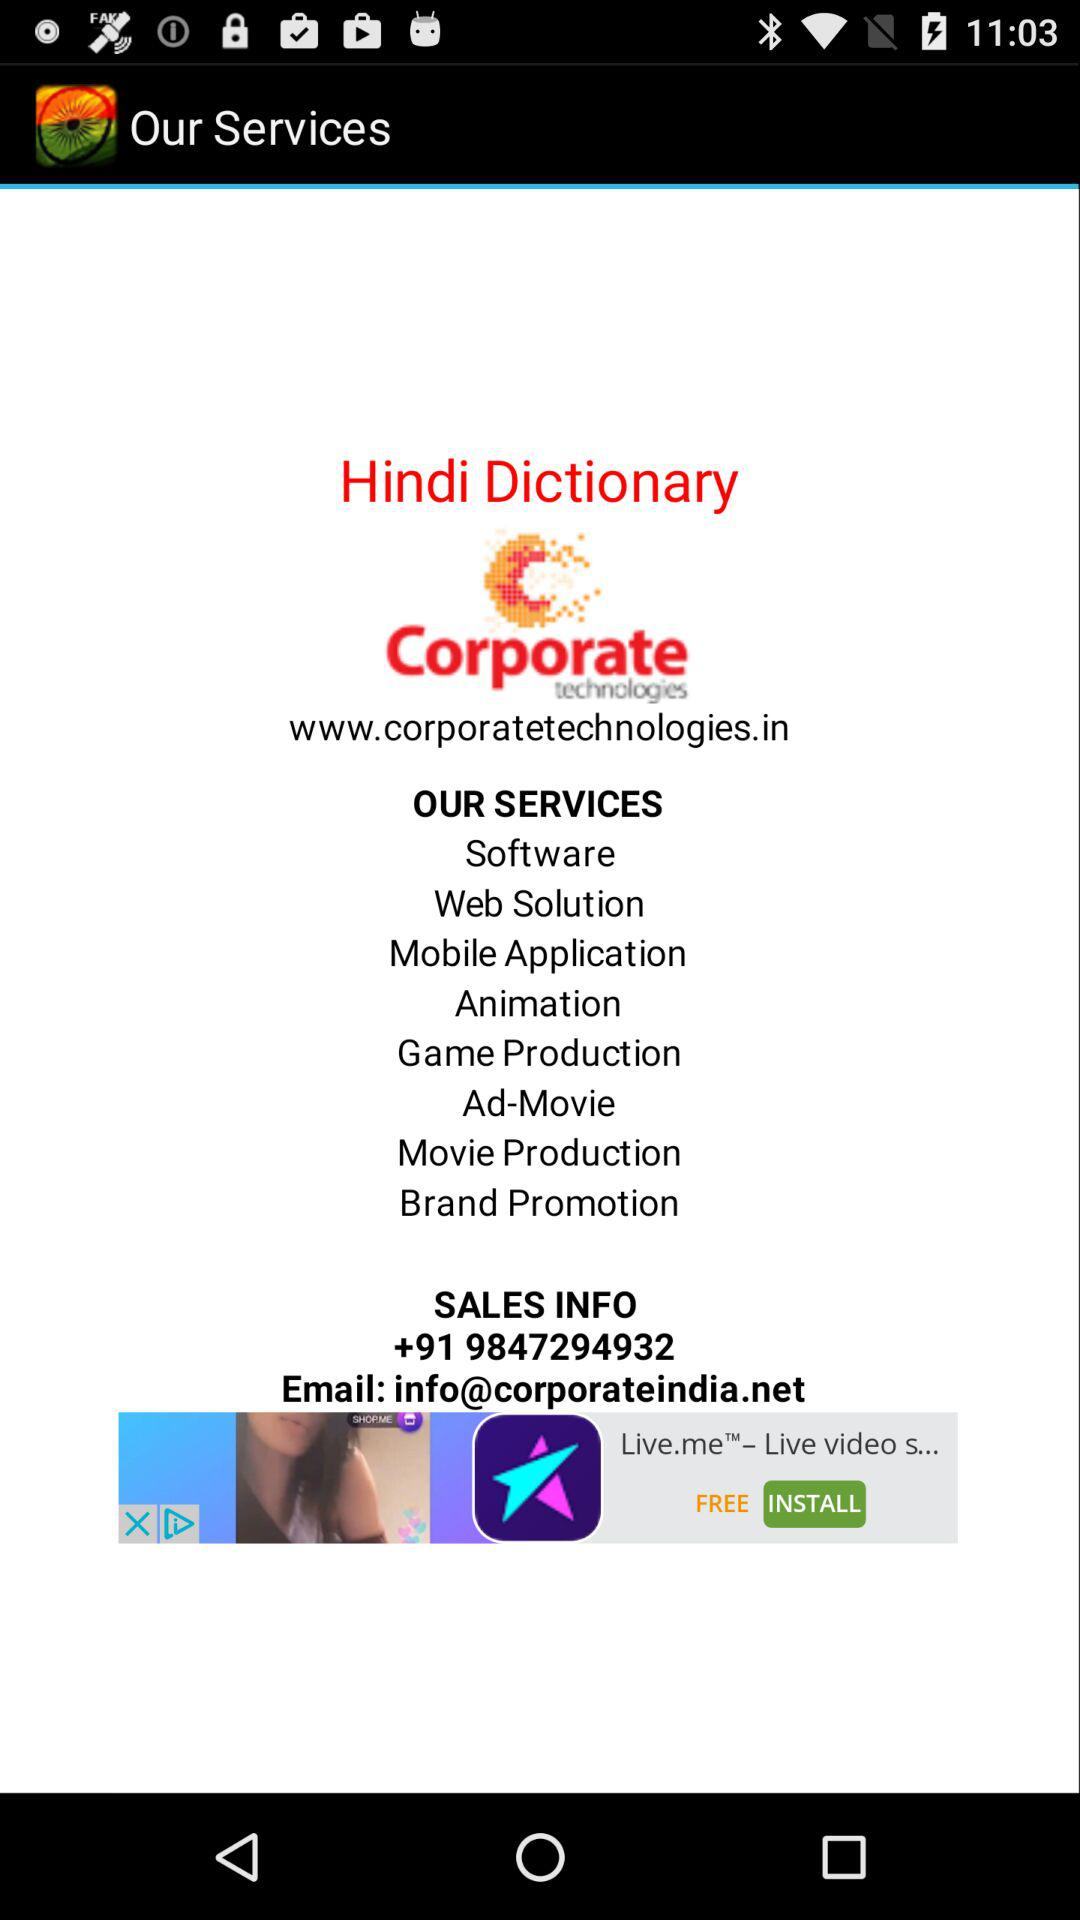What is the website of this company? The website of this company is www.corporatetechnologies.in. 